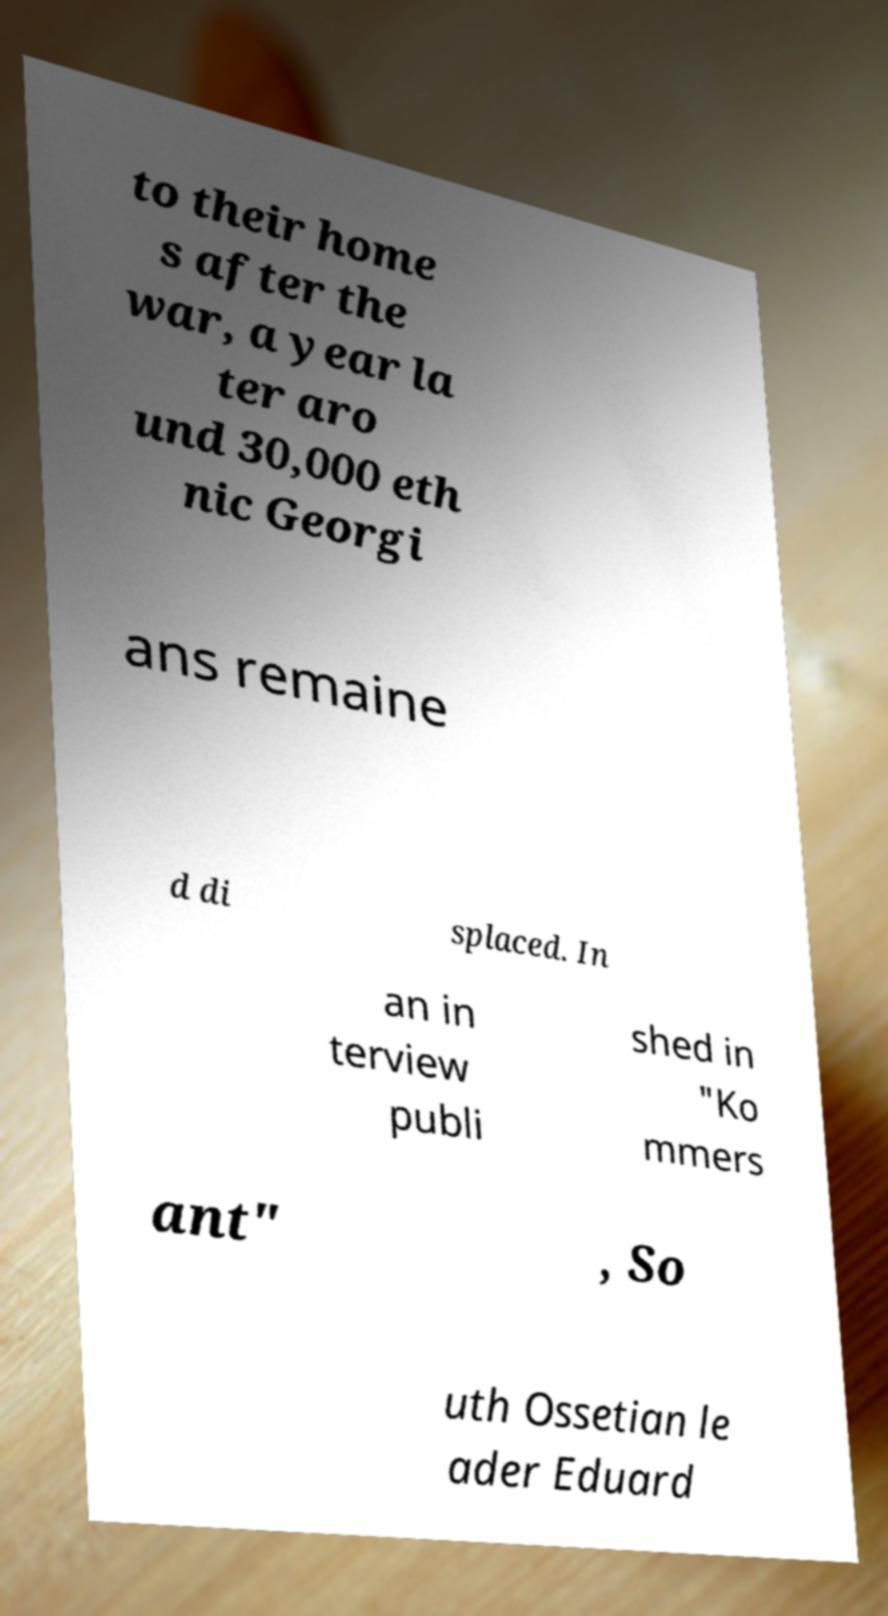Can you accurately transcribe the text from the provided image for me? to their home s after the war, a year la ter aro und 30,000 eth nic Georgi ans remaine d di splaced. In an in terview publi shed in "Ko mmers ant" , So uth Ossetian le ader Eduard 